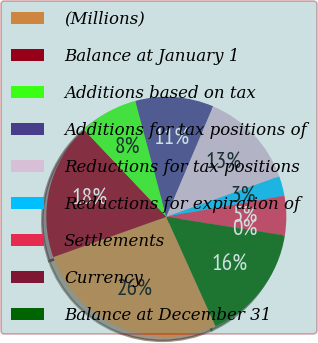Convert chart to OTSL. <chart><loc_0><loc_0><loc_500><loc_500><pie_chart><fcel>(Millions)<fcel>Balance at January 1<fcel>Additions based on tax<fcel>Additions for tax positions of<fcel>Reductions for tax positions<fcel>Reductions for expiration of<fcel>Settlements<fcel>Currency<fcel>Balance at December 31<nl><fcel>26.28%<fcel>18.4%<fcel>7.9%<fcel>10.53%<fcel>13.15%<fcel>2.65%<fcel>5.28%<fcel>0.03%<fcel>15.78%<nl></chart> 